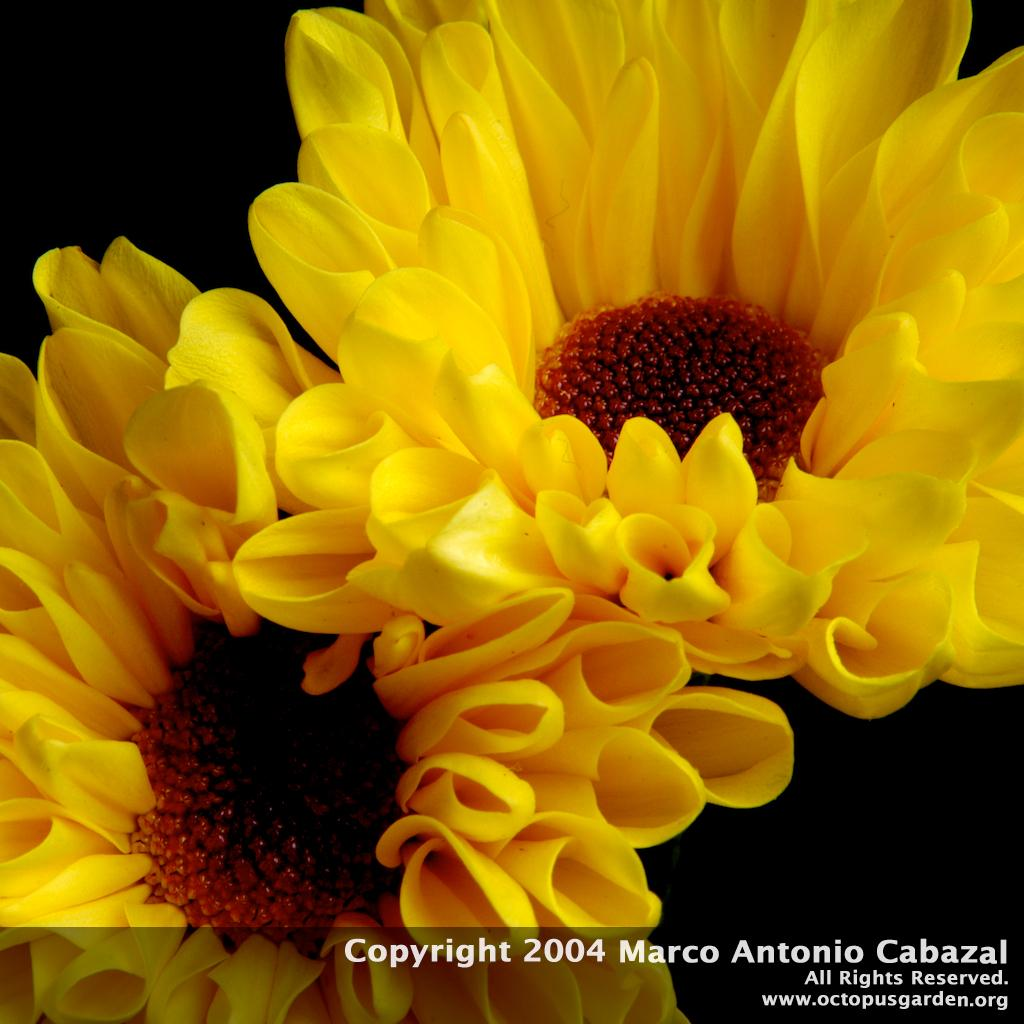What type of living organisms can be seen in the image? There are flowers in the image. Can you describe any additional features of the image? Yes, there is a watermark at the bottom of the image. What is the color of the background in the image? The background of the image is dark. How many kitties are sleeping on the desk in the image? There is no desk or kitties present in the image; it features flowers and a watermark. 